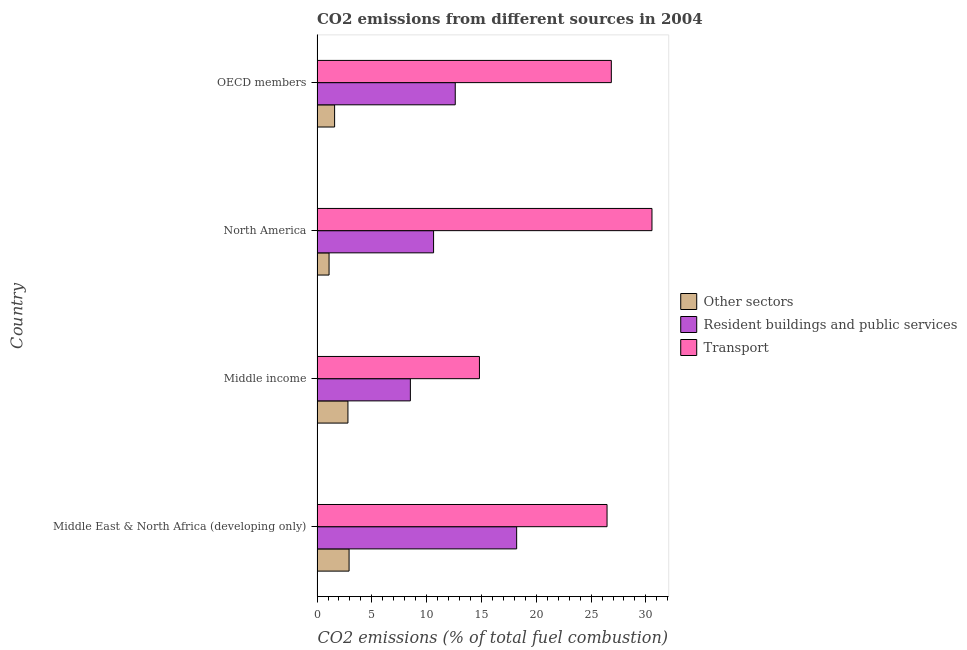Are the number of bars per tick equal to the number of legend labels?
Your response must be concise. Yes. What is the label of the 3rd group of bars from the top?
Provide a succinct answer. Middle income. What is the percentage of co2 emissions from resident buildings and public services in North America?
Your response must be concise. 10.63. Across all countries, what is the maximum percentage of co2 emissions from other sectors?
Ensure brevity in your answer.  2.92. Across all countries, what is the minimum percentage of co2 emissions from other sectors?
Your answer should be compact. 1.1. In which country was the percentage of co2 emissions from resident buildings and public services maximum?
Make the answer very short. Middle East & North Africa (developing only). What is the total percentage of co2 emissions from resident buildings and public services in the graph?
Offer a very short reply. 49.96. What is the difference between the percentage of co2 emissions from transport in Middle income and that in North America?
Provide a succinct answer. -15.74. What is the difference between the percentage of co2 emissions from transport in North America and the percentage of co2 emissions from other sectors in Middle East & North Africa (developing only)?
Offer a very short reply. 27.63. What is the average percentage of co2 emissions from resident buildings and public services per country?
Provide a succinct answer. 12.49. What is the difference between the percentage of co2 emissions from other sectors and percentage of co2 emissions from resident buildings and public services in OECD members?
Offer a terse response. -11.01. What is the ratio of the percentage of co2 emissions from resident buildings and public services in Middle income to that in OECD members?
Your response must be concise. 0.68. What is the difference between the highest and the second highest percentage of co2 emissions from other sectors?
Keep it short and to the point. 0.1. In how many countries, is the percentage of co2 emissions from other sectors greater than the average percentage of co2 emissions from other sectors taken over all countries?
Your answer should be very brief. 2. What does the 1st bar from the top in Middle East & North Africa (developing only) represents?
Offer a terse response. Transport. What does the 3rd bar from the bottom in Middle East & North Africa (developing only) represents?
Offer a very short reply. Transport. Is it the case that in every country, the sum of the percentage of co2 emissions from other sectors and percentage of co2 emissions from resident buildings and public services is greater than the percentage of co2 emissions from transport?
Provide a succinct answer. No. How many countries are there in the graph?
Ensure brevity in your answer.  4. What is the difference between two consecutive major ticks on the X-axis?
Your answer should be very brief. 5. Are the values on the major ticks of X-axis written in scientific E-notation?
Give a very brief answer. No. Does the graph contain any zero values?
Keep it short and to the point. No. What is the title of the graph?
Offer a very short reply. CO2 emissions from different sources in 2004. Does "Methane" appear as one of the legend labels in the graph?
Provide a short and direct response. No. What is the label or title of the X-axis?
Your answer should be compact. CO2 emissions (% of total fuel combustion). What is the CO2 emissions (% of total fuel combustion) in Other sectors in Middle East & North Africa (developing only)?
Your answer should be compact. 2.92. What is the CO2 emissions (% of total fuel combustion) in Resident buildings and public services in Middle East & North Africa (developing only)?
Your response must be concise. 18.21. What is the CO2 emissions (% of total fuel combustion) of Transport in Middle East & North Africa (developing only)?
Ensure brevity in your answer.  26.46. What is the CO2 emissions (% of total fuel combustion) in Other sectors in Middle income?
Your response must be concise. 2.82. What is the CO2 emissions (% of total fuel combustion) in Resident buildings and public services in Middle income?
Make the answer very short. 8.51. What is the CO2 emissions (% of total fuel combustion) in Transport in Middle income?
Keep it short and to the point. 14.82. What is the CO2 emissions (% of total fuel combustion) in Other sectors in North America?
Provide a short and direct response. 1.1. What is the CO2 emissions (% of total fuel combustion) in Resident buildings and public services in North America?
Keep it short and to the point. 10.63. What is the CO2 emissions (% of total fuel combustion) of Transport in North America?
Provide a short and direct response. 30.56. What is the CO2 emissions (% of total fuel combustion) of Other sectors in OECD members?
Keep it short and to the point. 1.6. What is the CO2 emissions (% of total fuel combustion) of Resident buildings and public services in OECD members?
Provide a succinct answer. 12.61. What is the CO2 emissions (% of total fuel combustion) in Transport in OECD members?
Your answer should be compact. 26.85. Across all countries, what is the maximum CO2 emissions (% of total fuel combustion) of Other sectors?
Ensure brevity in your answer.  2.92. Across all countries, what is the maximum CO2 emissions (% of total fuel combustion) in Resident buildings and public services?
Offer a terse response. 18.21. Across all countries, what is the maximum CO2 emissions (% of total fuel combustion) in Transport?
Your response must be concise. 30.56. Across all countries, what is the minimum CO2 emissions (% of total fuel combustion) in Other sectors?
Keep it short and to the point. 1.1. Across all countries, what is the minimum CO2 emissions (% of total fuel combustion) of Resident buildings and public services?
Offer a very short reply. 8.51. Across all countries, what is the minimum CO2 emissions (% of total fuel combustion) in Transport?
Provide a short and direct response. 14.82. What is the total CO2 emissions (% of total fuel combustion) in Other sectors in the graph?
Give a very brief answer. 8.44. What is the total CO2 emissions (% of total fuel combustion) in Resident buildings and public services in the graph?
Ensure brevity in your answer.  49.96. What is the total CO2 emissions (% of total fuel combustion) in Transport in the graph?
Your answer should be very brief. 98.67. What is the difference between the CO2 emissions (% of total fuel combustion) in Other sectors in Middle East & North Africa (developing only) and that in Middle income?
Offer a very short reply. 0.1. What is the difference between the CO2 emissions (% of total fuel combustion) of Resident buildings and public services in Middle East & North Africa (developing only) and that in Middle income?
Ensure brevity in your answer.  9.7. What is the difference between the CO2 emissions (% of total fuel combustion) in Transport in Middle East & North Africa (developing only) and that in Middle income?
Provide a succinct answer. 11.64. What is the difference between the CO2 emissions (% of total fuel combustion) of Other sectors in Middle East & North Africa (developing only) and that in North America?
Offer a terse response. 1.82. What is the difference between the CO2 emissions (% of total fuel combustion) of Resident buildings and public services in Middle East & North Africa (developing only) and that in North America?
Provide a succinct answer. 7.58. What is the difference between the CO2 emissions (% of total fuel combustion) in Transport in Middle East & North Africa (developing only) and that in North America?
Offer a terse response. -4.1. What is the difference between the CO2 emissions (% of total fuel combustion) in Other sectors in Middle East & North Africa (developing only) and that in OECD members?
Your response must be concise. 1.32. What is the difference between the CO2 emissions (% of total fuel combustion) in Resident buildings and public services in Middle East & North Africa (developing only) and that in OECD members?
Provide a succinct answer. 5.6. What is the difference between the CO2 emissions (% of total fuel combustion) in Transport in Middle East & North Africa (developing only) and that in OECD members?
Your answer should be compact. -0.39. What is the difference between the CO2 emissions (% of total fuel combustion) in Other sectors in Middle income and that in North America?
Your response must be concise. 1.72. What is the difference between the CO2 emissions (% of total fuel combustion) of Resident buildings and public services in Middle income and that in North America?
Make the answer very short. -2.12. What is the difference between the CO2 emissions (% of total fuel combustion) of Transport in Middle income and that in North America?
Your answer should be very brief. -15.74. What is the difference between the CO2 emissions (% of total fuel combustion) in Other sectors in Middle income and that in OECD members?
Your answer should be very brief. 1.22. What is the difference between the CO2 emissions (% of total fuel combustion) in Resident buildings and public services in Middle income and that in OECD members?
Ensure brevity in your answer.  -4.09. What is the difference between the CO2 emissions (% of total fuel combustion) of Transport in Middle income and that in OECD members?
Offer a very short reply. -12.03. What is the difference between the CO2 emissions (% of total fuel combustion) in Other sectors in North America and that in OECD members?
Offer a terse response. -0.51. What is the difference between the CO2 emissions (% of total fuel combustion) in Resident buildings and public services in North America and that in OECD members?
Your answer should be compact. -1.98. What is the difference between the CO2 emissions (% of total fuel combustion) in Transport in North America and that in OECD members?
Offer a very short reply. 3.71. What is the difference between the CO2 emissions (% of total fuel combustion) of Other sectors in Middle East & North Africa (developing only) and the CO2 emissions (% of total fuel combustion) of Resident buildings and public services in Middle income?
Offer a terse response. -5.59. What is the difference between the CO2 emissions (% of total fuel combustion) of Other sectors in Middle East & North Africa (developing only) and the CO2 emissions (% of total fuel combustion) of Transport in Middle income?
Give a very brief answer. -11.89. What is the difference between the CO2 emissions (% of total fuel combustion) in Resident buildings and public services in Middle East & North Africa (developing only) and the CO2 emissions (% of total fuel combustion) in Transport in Middle income?
Keep it short and to the point. 3.4. What is the difference between the CO2 emissions (% of total fuel combustion) of Other sectors in Middle East & North Africa (developing only) and the CO2 emissions (% of total fuel combustion) of Resident buildings and public services in North America?
Your answer should be very brief. -7.71. What is the difference between the CO2 emissions (% of total fuel combustion) of Other sectors in Middle East & North Africa (developing only) and the CO2 emissions (% of total fuel combustion) of Transport in North America?
Your answer should be very brief. -27.63. What is the difference between the CO2 emissions (% of total fuel combustion) of Resident buildings and public services in Middle East & North Africa (developing only) and the CO2 emissions (% of total fuel combustion) of Transport in North America?
Your answer should be compact. -12.35. What is the difference between the CO2 emissions (% of total fuel combustion) of Other sectors in Middle East & North Africa (developing only) and the CO2 emissions (% of total fuel combustion) of Resident buildings and public services in OECD members?
Your answer should be very brief. -9.69. What is the difference between the CO2 emissions (% of total fuel combustion) of Other sectors in Middle East & North Africa (developing only) and the CO2 emissions (% of total fuel combustion) of Transport in OECD members?
Your answer should be very brief. -23.93. What is the difference between the CO2 emissions (% of total fuel combustion) of Resident buildings and public services in Middle East & North Africa (developing only) and the CO2 emissions (% of total fuel combustion) of Transport in OECD members?
Make the answer very short. -8.64. What is the difference between the CO2 emissions (% of total fuel combustion) in Other sectors in Middle income and the CO2 emissions (% of total fuel combustion) in Resident buildings and public services in North America?
Make the answer very short. -7.81. What is the difference between the CO2 emissions (% of total fuel combustion) of Other sectors in Middle income and the CO2 emissions (% of total fuel combustion) of Transport in North America?
Make the answer very short. -27.74. What is the difference between the CO2 emissions (% of total fuel combustion) in Resident buildings and public services in Middle income and the CO2 emissions (% of total fuel combustion) in Transport in North America?
Offer a terse response. -22.04. What is the difference between the CO2 emissions (% of total fuel combustion) in Other sectors in Middle income and the CO2 emissions (% of total fuel combustion) in Resident buildings and public services in OECD members?
Provide a short and direct response. -9.79. What is the difference between the CO2 emissions (% of total fuel combustion) in Other sectors in Middle income and the CO2 emissions (% of total fuel combustion) in Transport in OECD members?
Give a very brief answer. -24.03. What is the difference between the CO2 emissions (% of total fuel combustion) in Resident buildings and public services in Middle income and the CO2 emissions (% of total fuel combustion) in Transport in OECD members?
Keep it short and to the point. -18.33. What is the difference between the CO2 emissions (% of total fuel combustion) in Other sectors in North America and the CO2 emissions (% of total fuel combustion) in Resident buildings and public services in OECD members?
Your answer should be very brief. -11.51. What is the difference between the CO2 emissions (% of total fuel combustion) in Other sectors in North America and the CO2 emissions (% of total fuel combustion) in Transport in OECD members?
Your answer should be compact. -25.75. What is the difference between the CO2 emissions (% of total fuel combustion) in Resident buildings and public services in North America and the CO2 emissions (% of total fuel combustion) in Transport in OECD members?
Offer a very short reply. -16.22. What is the average CO2 emissions (% of total fuel combustion) of Other sectors per country?
Offer a terse response. 2.11. What is the average CO2 emissions (% of total fuel combustion) of Resident buildings and public services per country?
Offer a terse response. 12.49. What is the average CO2 emissions (% of total fuel combustion) of Transport per country?
Provide a succinct answer. 24.67. What is the difference between the CO2 emissions (% of total fuel combustion) in Other sectors and CO2 emissions (% of total fuel combustion) in Resident buildings and public services in Middle East & North Africa (developing only)?
Give a very brief answer. -15.29. What is the difference between the CO2 emissions (% of total fuel combustion) of Other sectors and CO2 emissions (% of total fuel combustion) of Transport in Middle East & North Africa (developing only)?
Ensure brevity in your answer.  -23.54. What is the difference between the CO2 emissions (% of total fuel combustion) in Resident buildings and public services and CO2 emissions (% of total fuel combustion) in Transport in Middle East & North Africa (developing only)?
Your answer should be very brief. -8.25. What is the difference between the CO2 emissions (% of total fuel combustion) of Other sectors and CO2 emissions (% of total fuel combustion) of Resident buildings and public services in Middle income?
Your response must be concise. -5.7. What is the difference between the CO2 emissions (% of total fuel combustion) in Other sectors and CO2 emissions (% of total fuel combustion) in Transport in Middle income?
Ensure brevity in your answer.  -12. What is the difference between the CO2 emissions (% of total fuel combustion) in Resident buildings and public services and CO2 emissions (% of total fuel combustion) in Transport in Middle income?
Your answer should be very brief. -6.3. What is the difference between the CO2 emissions (% of total fuel combustion) in Other sectors and CO2 emissions (% of total fuel combustion) in Resident buildings and public services in North America?
Your answer should be compact. -9.53. What is the difference between the CO2 emissions (% of total fuel combustion) in Other sectors and CO2 emissions (% of total fuel combustion) in Transport in North America?
Offer a very short reply. -29.46. What is the difference between the CO2 emissions (% of total fuel combustion) of Resident buildings and public services and CO2 emissions (% of total fuel combustion) of Transport in North America?
Provide a succinct answer. -19.92. What is the difference between the CO2 emissions (% of total fuel combustion) of Other sectors and CO2 emissions (% of total fuel combustion) of Resident buildings and public services in OECD members?
Keep it short and to the point. -11.01. What is the difference between the CO2 emissions (% of total fuel combustion) of Other sectors and CO2 emissions (% of total fuel combustion) of Transport in OECD members?
Provide a short and direct response. -25.25. What is the difference between the CO2 emissions (% of total fuel combustion) in Resident buildings and public services and CO2 emissions (% of total fuel combustion) in Transport in OECD members?
Your answer should be compact. -14.24. What is the ratio of the CO2 emissions (% of total fuel combustion) of Other sectors in Middle East & North Africa (developing only) to that in Middle income?
Ensure brevity in your answer.  1.04. What is the ratio of the CO2 emissions (% of total fuel combustion) in Resident buildings and public services in Middle East & North Africa (developing only) to that in Middle income?
Provide a succinct answer. 2.14. What is the ratio of the CO2 emissions (% of total fuel combustion) of Transport in Middle East & North Africa (developing only) to that in Middle income?
Keep it short and to the point. 1.79. What is the ratio of the CO2 emissions (% of total fuel combustion) in Other sectors in Middle East & North Africa (developing only) to that in North America?
Offer a very short reply. 2.66. What is the ratio of the CO2 emissions (% of total fuel combustion) of Resident buildings and public services in Middle East & North Africa (developing only) to that in North America?
Keep it short and to the point. 1.71. What is the ratio of the CO2 emissions (% of total fuel combustion) of Transport in Middle East & North Africa (developing only) to that in North America?
Your response must be concise. 0.87. What is the ratio of the CO2 emissions (% of total fuel combustion) of Other sectors in Middle East & North Africa (developing only) to that in OECD members?
Ensure brevity in your answer.  1.82. What is the ratio of the CO2 emissions (% of total fuel combustion) of Resident buildings and public services in Middle East & North Africa (developing only) to that in OECD members?
Your response must be concise. 1.44. What is the ratio of the CO2 emissions (% of total fuel combustion) in Transport in Middle East & North Africa (developing only) to that in OECD members?
Your answer should be compact. 0.99. What is the ratio of the CO2 emissions (% of total fuel combustion) of Other sectors in Middle income to that in North America?
Your answer should be very brief. 2.57. What is the ratio of the CO2 emissions (% of total fuel combustion) in Resident buildings and public services in Middle income to that in North America?
Your answer should be compact. 0.8. What is the ratio of the CO2 emissions (% of total fuel combustion) of Transport in Middle income to that in North America?
Keep it short and to the point. 0.48. What is the ratio of the CO2 emissions (% of total fuel combustion) in Other sectors in Middle income to that in OECD members?
Offer a terse response. 1.76. What is the ratio of the CO2 emissions (% of total fuel combustion) of Resident buildings and public services in Middle income to that in OECD members?
Make the answer very short. 0.68. What is the ratio of the CO2 emissions (% of total fuel combustion) of Transport in Middle income to that in OECD members?
Provide a succinct answer. 0.55. What is the ratio of the CO2 emissions (% of total fuel combustion) in Other sectors in North America to that in OECD members?
Offer a very short reply. 0.68. What is the ratio of the CO2 emissions (% of total fuel combustion) in Resident buildings and public services in North America to that in OECD members?
Make the answer very short. 0.84. What is the ratio of the CO2 emissions (% of total fuel combustion) in Transport in North America to that in OECD members?
Your answer should be very brief. 1.14. What is the difference between the highest and the second highest CO2 emissions (% of total fuel combustion) in Other sectors?
Offer a terse response. 0.1. What is the difference between the highest and the second highest CO2 emissions (% of total fuel combustion) of Resident buildings and public services?
Your answer should be compact. 5.6. What is the difference between the highest and the second highest CO2 emissions (% of total fuel combustion) in Transport?
Give a very brief answer. 3.71. What is the difference between the highest and the lowest CO2 emissions (% of total fuel combustion) in Other sectors?
Your response must be concise. 1.82. What is the difference between the highest and the lowest CO2 emissions (% of total fuel combustion) in Resident buildings and public services?
Keep it short and to the point. 9.7. What is the difference between the highest and the lowest CO2 emissions (% of total fuel combustion) of Transport?
Ensure brevity in your answer.  15.74. 